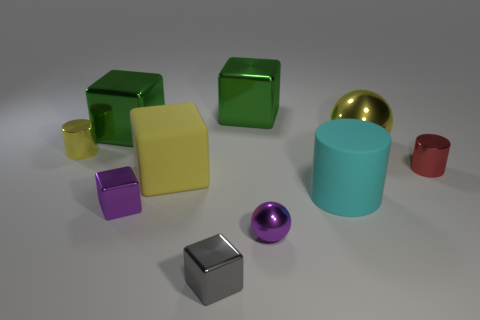Does the small block behind the tiny gray metallic thing have the same color as the ball in front of the big rubber cube?
Your response must be concise. Yes. There is a tiny purple metallic sphere; what number of large blocks are on the right side of it?
Keep it short and to the point. 0. Are there any big balls that are in front of the green object to the right of the small purple thing behind the purple ball?
Your answer should be compact. Yes. How many cylinders have the same size as the gray object?
Give a very brief answer. 2. What is the material of the purple cube on the left side of the shiny cylinder right of the big rubber block?
Provide a short and direct response. Metal. What is the shape of the tiny object that is right of the matte object that is right of the yellow thing that is in front of the small yellow object?
Keep it short and to the point. Cylinder. There is a yellow metal object that is on the right side of the tiny yellow thing; does it have the same shape as the purple metal thing in front of the small purple block?
Offer a terse response. Yes. What number of other objects are there of the same material as the tiny yellow cylinder?
Provide a succinct answer. 7. There is a gray thing that is the same material as the tiny yellow object; what is its shape?
Ensure brevity in your answer.  Cube. Do the rubber block and the cyan rubber thing have the same size?
Give a very brief answer. Yes. 